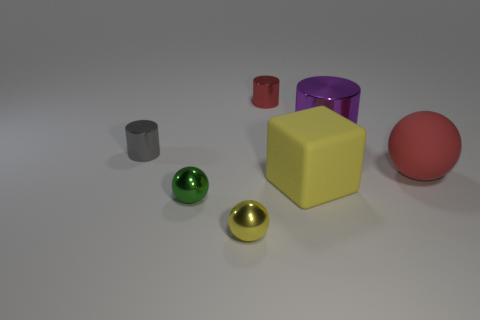How many small spheres are the same color as the matte cube?
Your response must be concise. 1. Are there any other things of the same color as the large sphere?
Give a very brief answer. Yes. Are there more big yellow blocks than small rubber cylinders?
Your answer should be compact. Yes. There is a small shiny cylinder behind the gray object; is its color the same as the big rubber sphere in front of the gray metal cylinder?
Offer a terse response. Yes. Are there any gray cylinders that are behind the shiny cylinder to the right of the red metallic thing?
Provide a succinct answer. No. Is the number of purple objects on the right side of the purple cylinder less than the number of large purple cylinders that are behind the yellow block?
Your response must be concise. Yes. Is the tiny cylinder in front of the tiny red cylinder made of the same material as the tiny sphere that is to the right of the tiny green shiny thing?
Provide a short and direct response. Yes. What number of tiny objects are blue matte balls or red rubber spheres?
Give a very brief answer. 0. What shape is the large object that is the same material as the tiny gray cylinder?
Ensure brevity in your answer.  Cylinder. Is the number of gray metal cylinders right of the big yellow object less than the number of small yellow matte spheres?
Keep it short and to the point. No. 